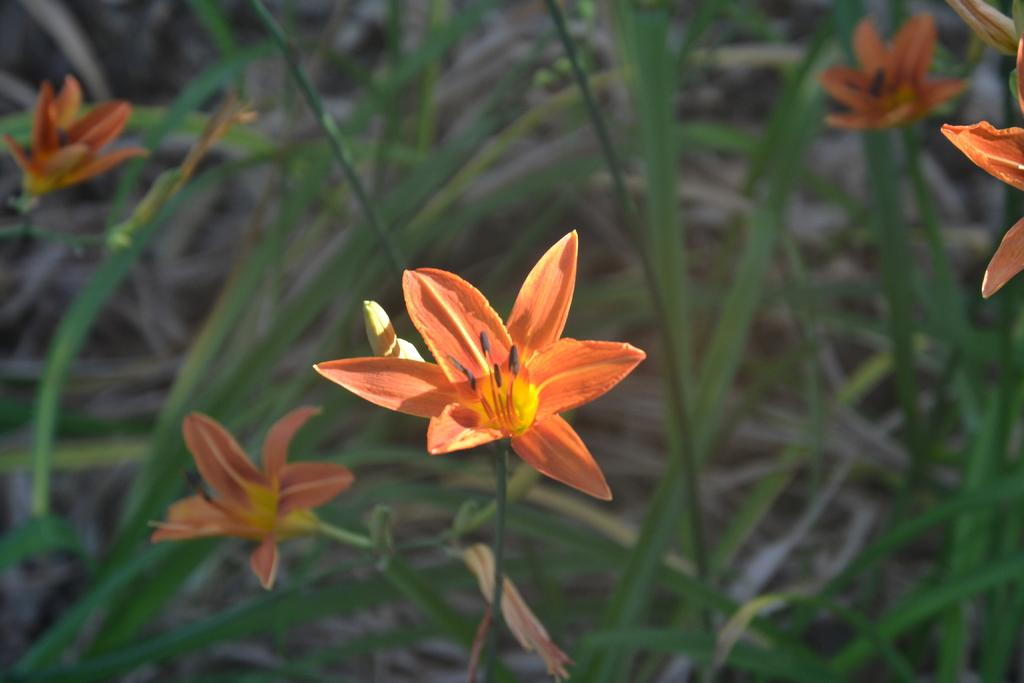What type of living organisms can be seen in the image? Plants can be seen in the image. What features are present on the plants? The plants have flowers and leaves. What type of harmony can be heard in the image? There is no audible sound in the image, so it is not possible to determine if any harmony can be heard. 